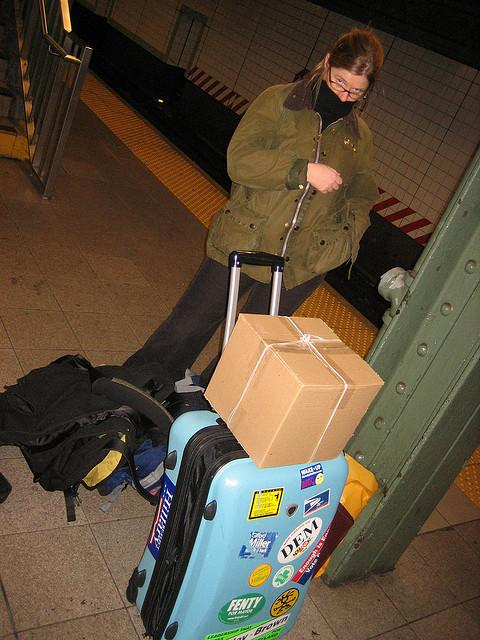What type of area is the woman waiting in? train station 